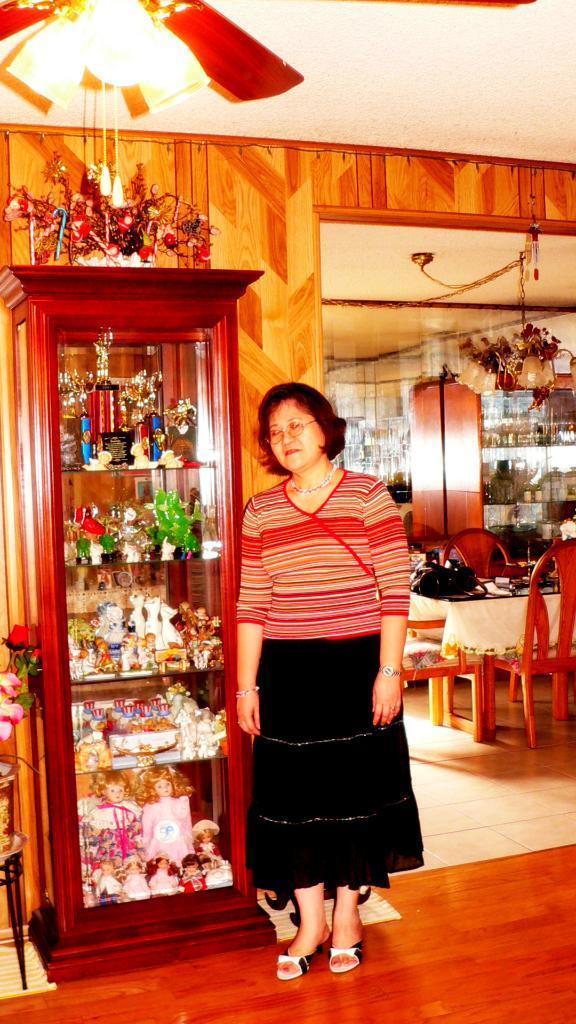In one or two sentences, can you explain what this image depicts? In this image I can see a woman is standing, I can also see she is wearing a specs. In the background I can see few chairs, a table, a bag and few more stuffs. 